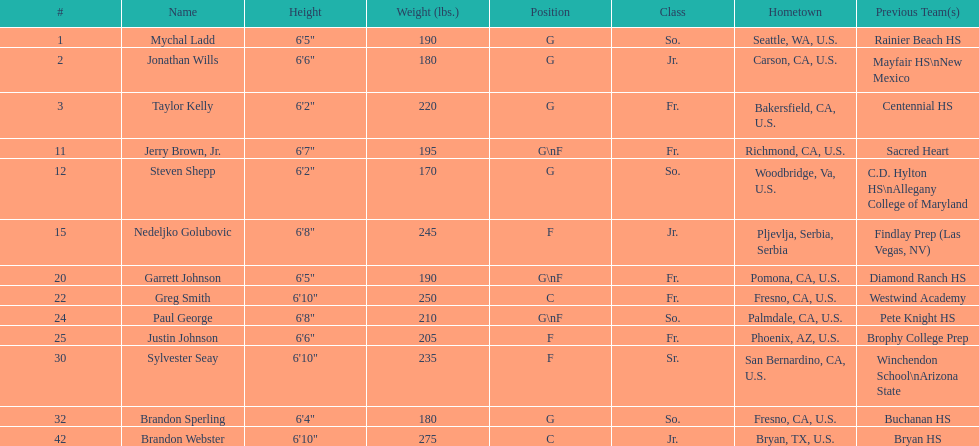How many players hometowns are outside of california? 5. 